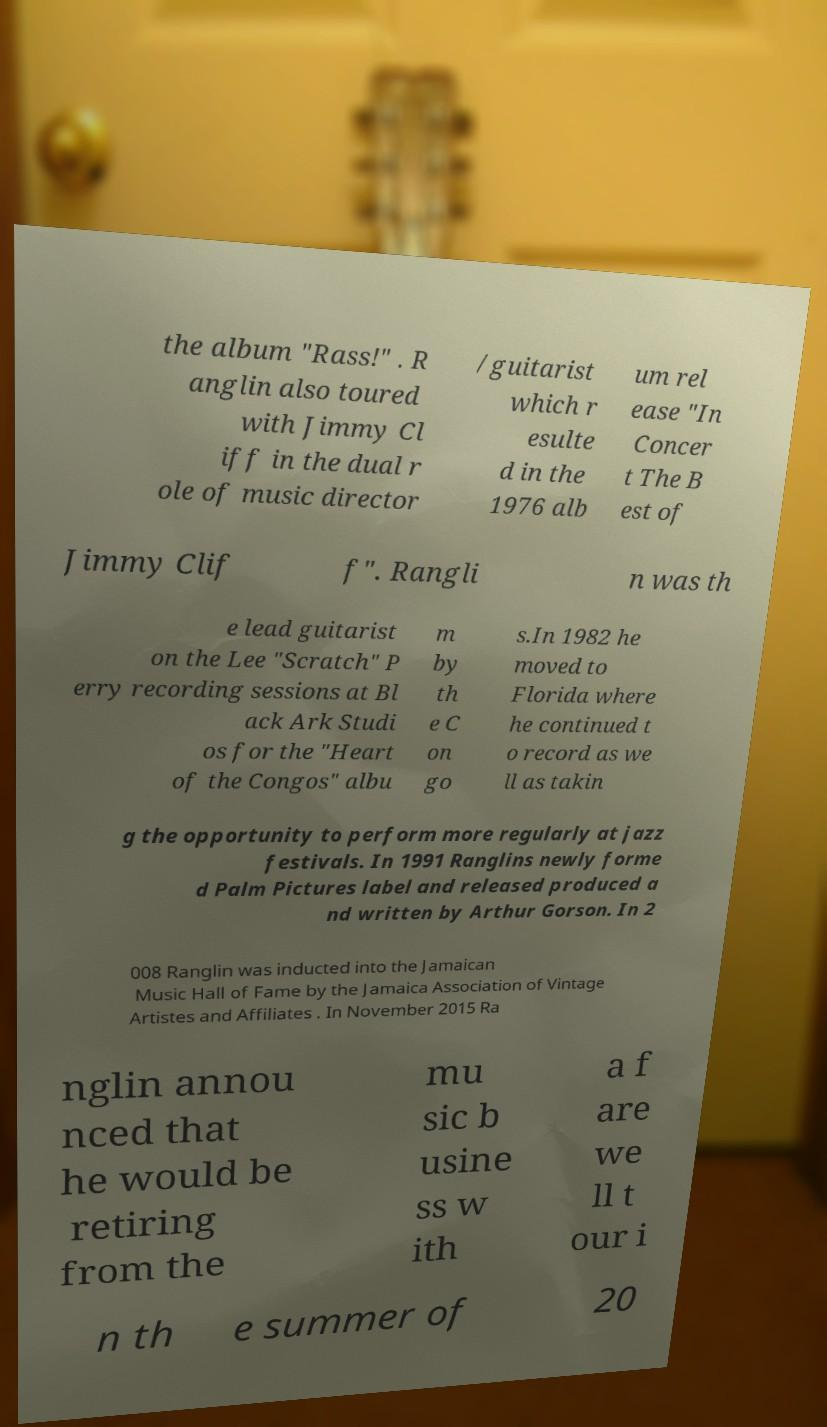There's text embedded in this image that I need extracted. Can you transcribe it verbatim? the album "Rass!" . R anglin also toured with Jimmy Cl iff in the dual r ole of music director /guitarist which r esulte d in the 1976 alb um rel ease "In Concer t The B est of Jimmy Clif f". Rangli n was th e lead guitarist on the Lee "Scratch" P erry recording sessions at Bl ack Ark Studi os for the "Heart of the Congos" albu m by th e C on go s.In 1982 he moved to Florida where he continued t o record as we ll as takin g the opportunity to perform more regularly at jazz festivals. In 1991 Ranglins newly forme d Palm Pictures label and released produced a nd written by Arthur Gorson. In 2 008 Ranglin was inducted into the Jamaican Music Hall of Fame by the Jamaica Association of Vintage Artistes and Affiliates . In November 2015 Ra nglin annou nced that he would be retiring from the mu sic b usine ss w ith a f are we ll t our i n th e summer of 20 